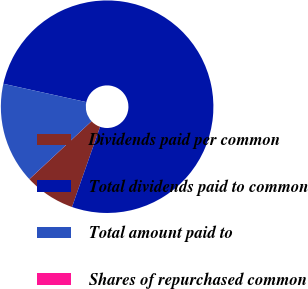Convert chart to OTSL. <chart><loc_0><loc_0><loc_500><loc_500><pie_chart><fcel>Dividends paid per common<fcel>Total dividends paid to common<fcel>Total amount paid to<fcel>Shares of repurchased common<nl><fcel>7.7%<fcel>76.89%<fcel>15.39%<fcel>0.01%<nl></chart> 